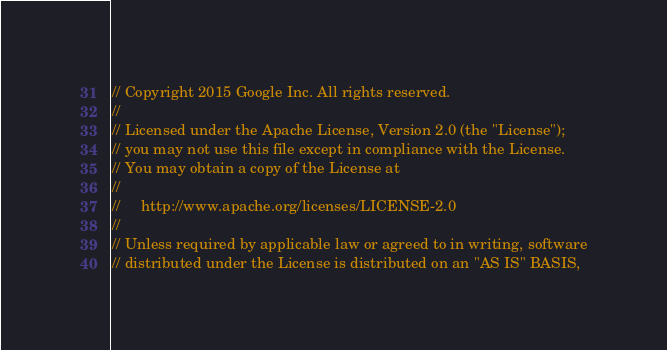<code> <loc_0><loc_0><loc_500><loc_500><_C++_>// Copyright 2015 Google Inc. All rights reserved.
//
// Licensed under the Apache License, Version 2.0 (the "License");
// you may not use this file except in compliance with the License.
// You may obtain a copy of the License at
//
//     http://www.apache.org/licenses/LICENSE-2.0
//
// Unless required by applicable law or agreed to in writing, software
// distributed under the License is distributed on an "AS IS" BASIS,</code> 